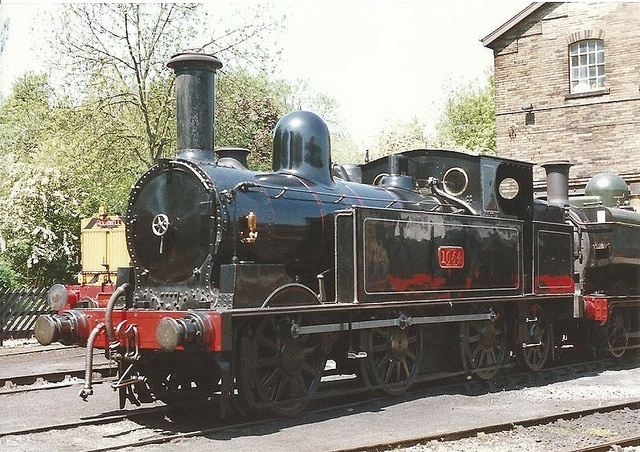Describe the objects in this image and their specific colors. I can see a train in gray, black, and darkgray tones in this image. 